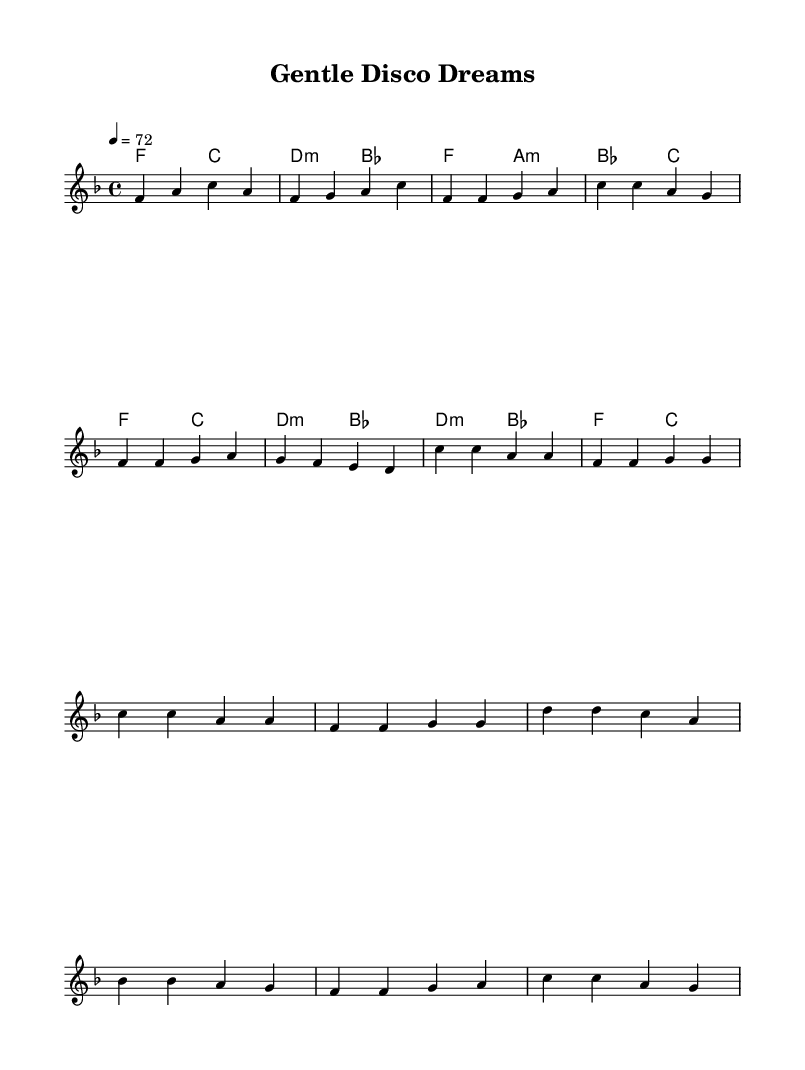What is the key signature of this music? The key signature is indicated at the beginning of the staff where it shows one flat, which corresponds to F major.
Answer: F major What is the time signature of this music? The time signature appears at the beginning of the score, shown as a fraction-like notation with a four on top and a four on the bottom, which indicates four beats per measure.
Answer: 4/4 What is the tempo marking of this piece? The tempo is indicated by the notation '4 = 72' under the global settings, which signifies that there should be 72 beats per minute at the speed of a quarter note.
Answer: 72 How many measures are in the chorus section? By reviewing the written music, the chorus section consists of four measures, as counted in the score.
Answer: 4 What is the highest pitch note in the melody? The melody section shows a note labeled c' which is placed above the staff, indicating it is the highest pitch.
Answer: c' What type of chords are used in the bridge? The chords in the bridge section include d minor and b flat, which are typical harmonic structures found in smoother disco ballads, suggesting their quality is minor and adds emotional depth.
Answer: d minor, b flat What instrument is indicated to play this part? The label "Staff" in the score indicates that this part is meant to be played by a musical instrument, in this case, likely a piano or synthesizer, based on disco arrangements.
Answer: Lead 